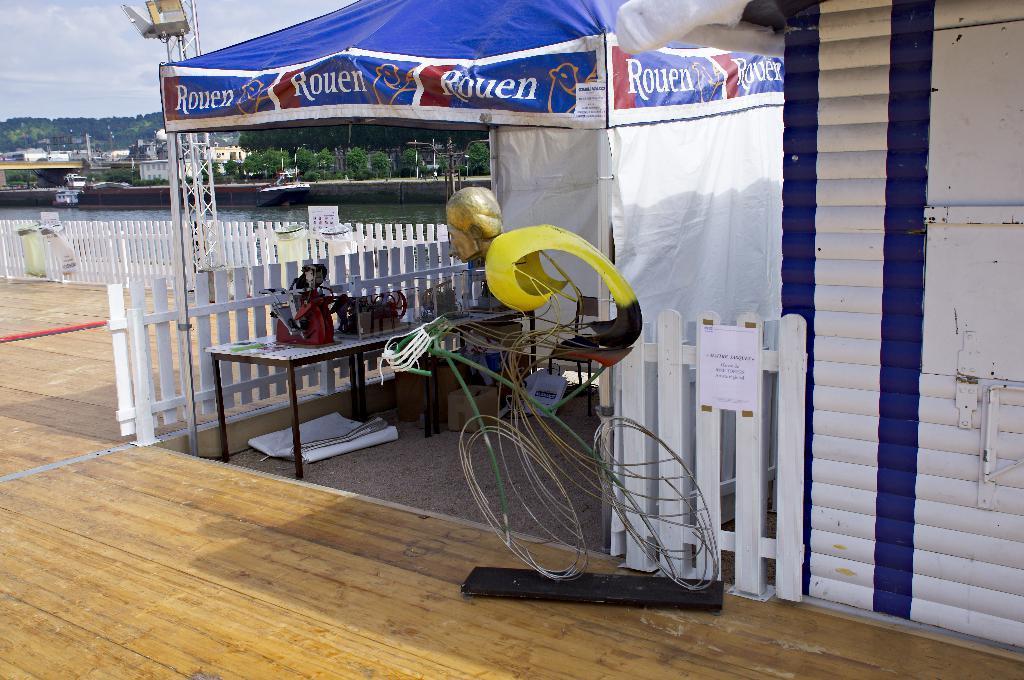In one or two sentences, can you explain what this image depicts? In this image there is a statue on the wooden floor. Left side there is a table having few objects are on it. The table is under the tent. Left side there is a wall. Behind there is a water. Beside there is a wall. Left side there are few buildings and trees. Left top there is sky. Right side house. Beside there is a fence having a poster attached to it. 